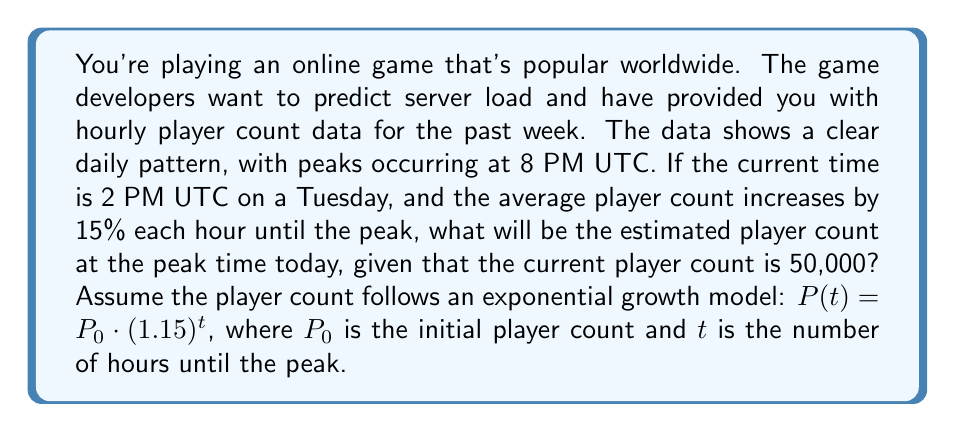Provide a solution to this math problem. To solve this problem, we'll use the exponential growth model provided:

$P(t) = P_0 \cdot (1.15)^t$

Where:
$P(t)$ is the player count after $t$ hours
$P_0$ is the initial player count (50,000)
$t$ is the number of hours until the peak

1. First, let's determine the number of hours from 2 PM to 8 PM:
   8 PM - 2 PM = 6 hours

2. Now we can plug these values into our equation:
   $P(6) = 50,000 \cdot (1.15)^6$

3. Let's calculate this step-by-step:
   $P(6) = 50,000 \cdot (1.15)^6$
   $= 50,000 \cdot 2.3131$
   $= 115,655$

4. Rounding to the nearest whole number (as we can't have fractional players):
   $P(6) \approx 115,655$ players

Therefore, the estimated player count at the peak time (8 PM UTC) will be approximately 115,655 players.
Answer: 115,655 players 